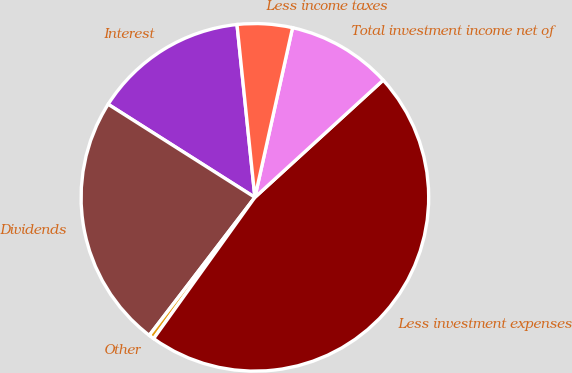<chart> <loc_0><loc_0><loc_500><loc_500><pie_chart><fcel>Interest<fcel>Dividends<fcel>Other<fcel>Less investment expenses<fcel>Total investment income net of<fcel>Less income taxes<nl><fcel>14.36%<fcel>23.6%<fcel>0.5%<fcel>46.68%<fcel>9.74%<fcel>5.12%<nl></chart> 